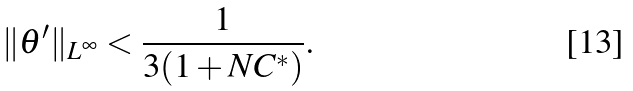Convert formula to latex. <formula><loc_0><loc_0><loc_500><loc_500>\| \theta ^ { \prime } \| _ { L ^ { \infty } } < \frac { 1 } { 3 ( 1 + N C ^ { * } ) } .</formula> 